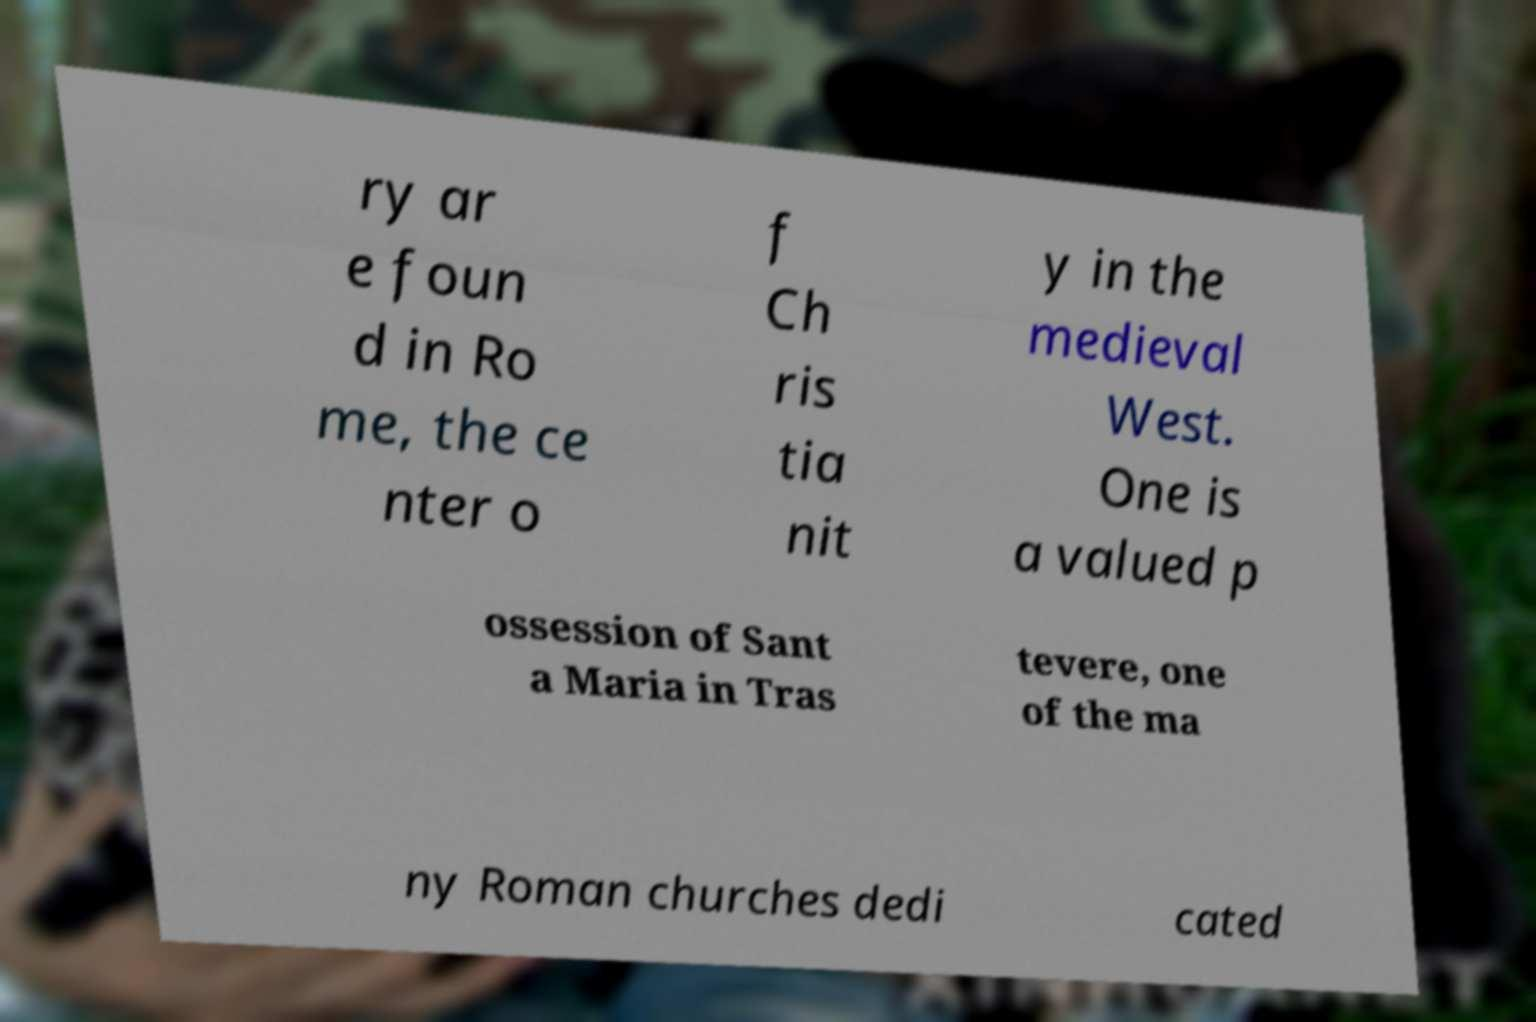There's text embedded in this image that I need extracted. Can you transcribe it verbatim? ry ar e foun d in Ro me, the ce nter o f Ch ris tia nit y in the medieval West. One is a valued p ossession of Sant a Maria in Tras tevere, one of the ma ny Roman churches dedi cated 